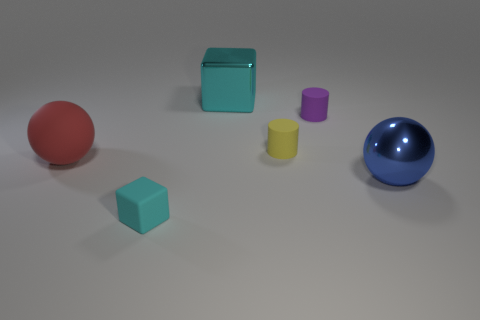Add 2 small blocks. How many objects exist? 8 Subtract all cylinders. How many objects are left? 4 Add 2 large blue objects. How many large blue objects are left? 3 Add 1 small red objects. How many small red objects exist? 1 Subtract 1 cyan blocks. How many objects are left? 5 Subtract all tiny blue matte things. Subtract all large blue objects. How many objects are left? 5 